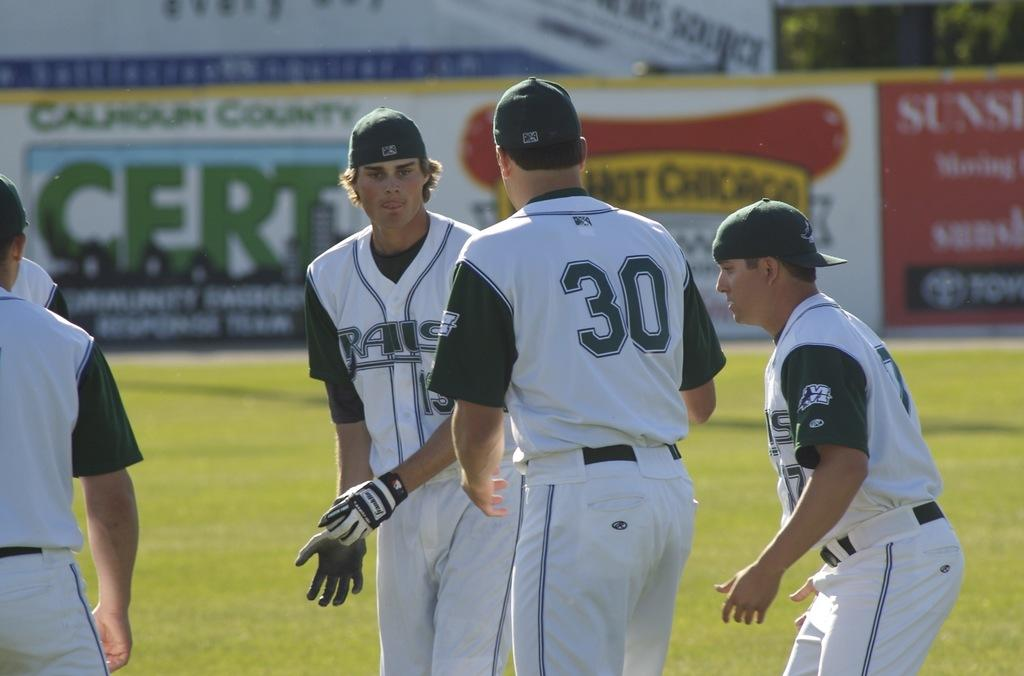<image>
Provide a brief description of the given image. A baseball player with the jersey number 30. 